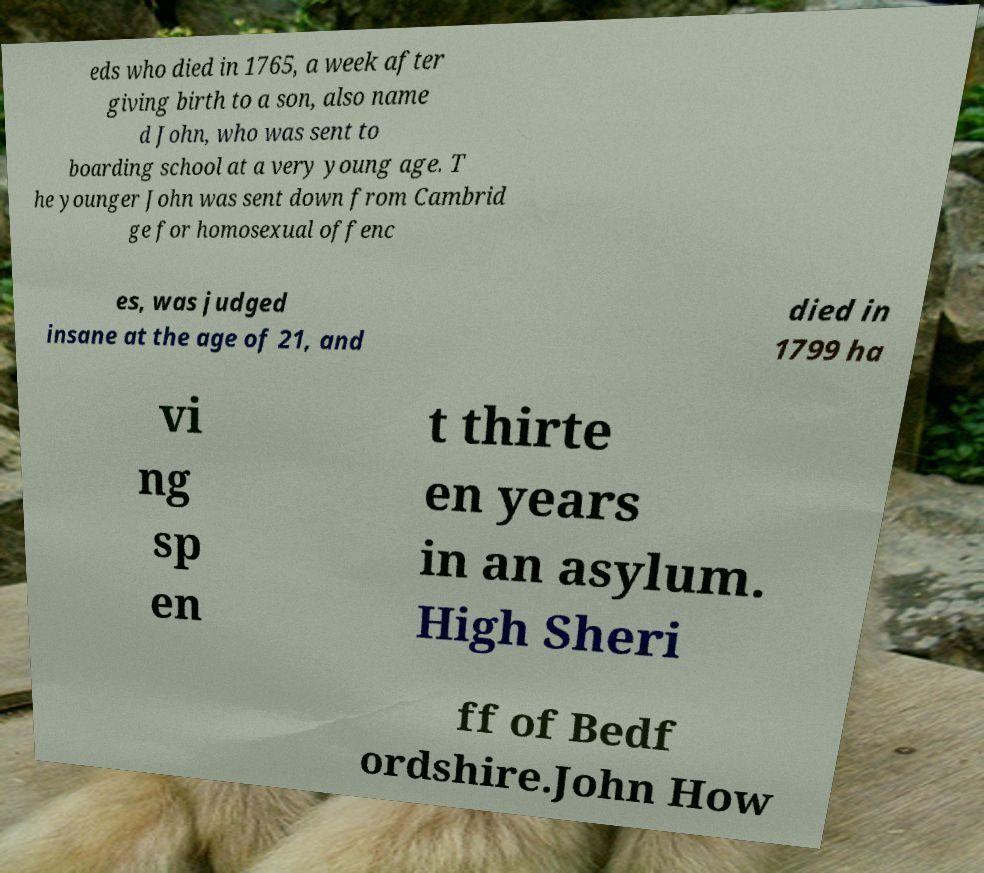Could you assist in decoding the text presented in this image and type it out clearly? eds who died in 1765, a week after giving birth to a son, also name d John, who was sent to boarding school at a very young age. T he younger John was sent down from Cambrid ge for homosexual offenc es, was judged insane at the age of 21, and died in 1799 ha vi ng sp en t thirte en years in an asylum. High Sheri ff of Bedf ordshire.John How 